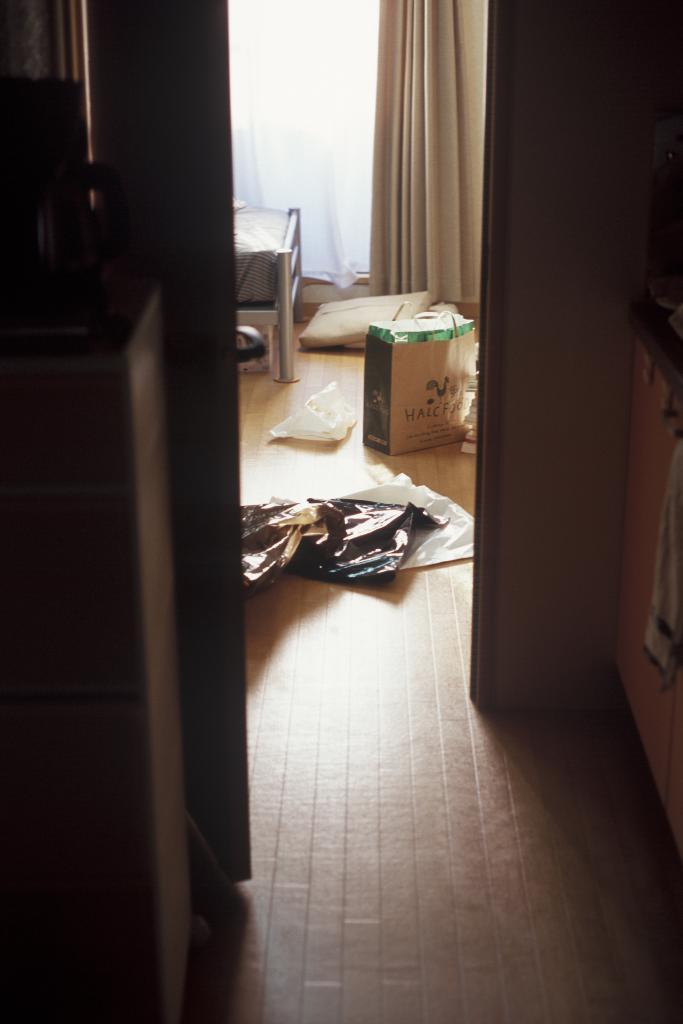Can you describe this image briefly? In the background we can see curtains. In this picture we can see carry bag, covers and objects. We can see the partial part of bed frame and bed. At the bottom portion of the picture we can see the floor. On the right side of the picture looks like cupboard doors and we can see a cloth. 